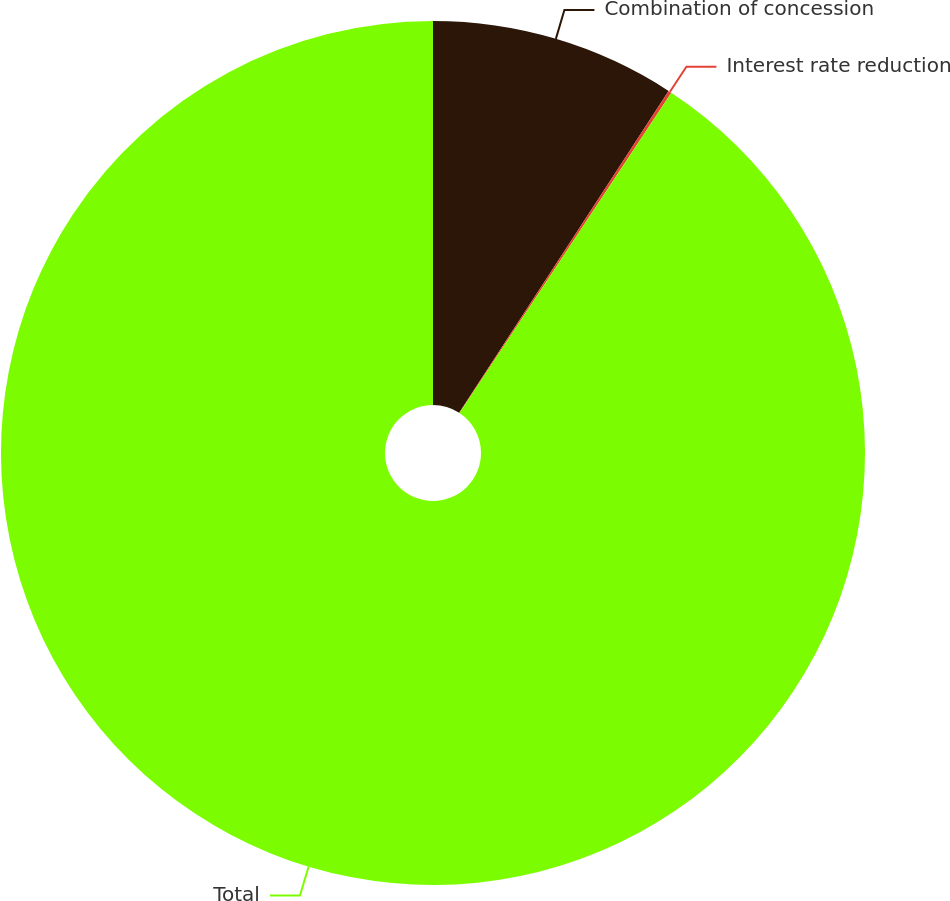Convert chart to OTSL. <chart><loc_0><loc_0><loc_500><loc_500><pie_chart><fcel>Combination of concession<fcel>Interest rate reduction<fcel>Total<nl><fcel>9.18%<fcel>0.12%<fcel>90.7%<nl></chart> 